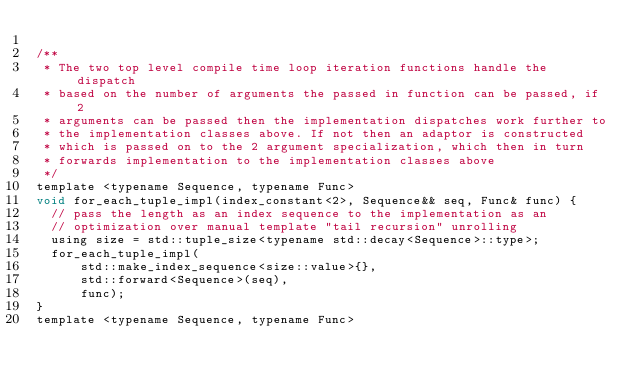<code> <loc_0><loc_0><loc_500><loc_500><_C_>
/**
 * The two top level compile time loop iteration functions handle the dispatch
 * based on the number of arguments the passed in function can be passed, if 2
 * arguments can be passed then the implementation dispatches work further to
 * the implementation classes above. If not then an adaptor is constructed
 * which is passed on to the 2 argument specialization, which then in turn
 * forwards implementation to the implementation classes above
 */
template <typename Sequence, typename Func>
void for_each_tuple_impl(index_constant<2>, Sequence&& seq, Func& func) {
  // pass the length as an index sequence to the implementation as an
  // optimization over manual template "tail recursion" unrolling
  using size = std::tuple_size<typename std::decay<Sequence>::type>;
  for_each_tuple_impl(
      std::make_index_sequence<size::value>{},
      std::forward<Sequence>(seq),
      func);
}
template <typename Sequence, typename Func></code> 